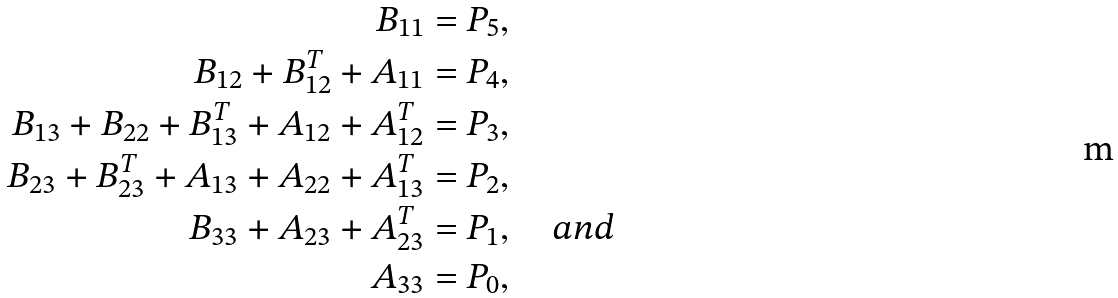<formula> <loc_0><loc_0><loc_500><loc_500>B _ { 1 1 } & = P _ { 5 } , \\ B _ { 1 2 } + B _ { 1 2 } ^ { T } + A _ { 1 1 } & = P _ { 4 } , \\ B _ { 1 3 } + B _ { 2 2 } + B _ { 1 3 } ^ { T } + A _ { 1 2 } + A _ { 1 2 } ^ { T } & = P _ { 3 } , \\ B _ { 2 3 } + B _ { 2 3 } ^ { T } + A _ { 1 3 } + A _ { 2 2 } + A _ { 1 3 } ^ { T } & = P _ { 2 } , \\ B _ { 3 3 } + A _ { 2 3 } + A _ { 2 3 } ^ { T } & = P _ { 1 } , \quad a n d \\ A _ { 3 3 } & = P _ { 0 } ,</formula> 